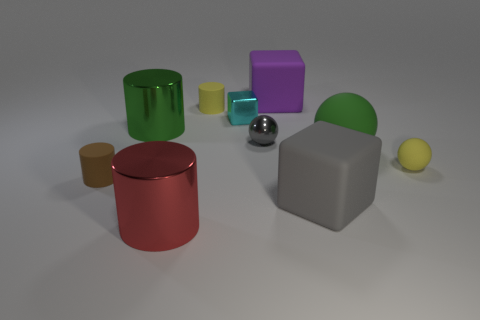What materials are the objects in the image made of? The objects in the image seem to be designed to imitate various materials. The yellow cylinder and the red can at the front look like they have a matte, painted metallic finish, while the grey cube and the purple block give off the impression of matte rubber. The green sphere and the smaller yellow ball could be representing a glossy plastic material, whereas the small shiny sphere in the center seems to simulate a polished metal look. 